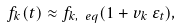Convert formula to latex. <formula><loc_0><loc_0><loc_500><loc_500>f _ { k } ( t ) \approx f _ { k , \ e q } ( 1 + v _ { k } \, \varepsilon _ { t } ) ,</formula> 